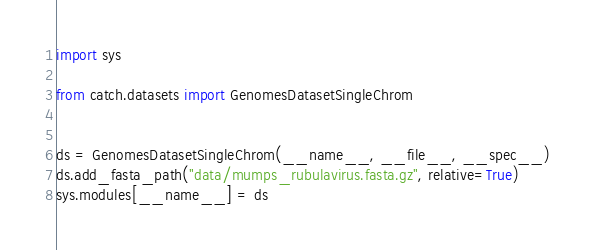<code> <loc_0><loc_0><loc_500><loc_500><_Python_>import sys

from catch.datasets import GenomesDatasetSingleChrom


ds = GenomesDatasetSingleChrom(__name__, __file__, __spec__)
ds.add_fasta_path("data/mumps_rubulavirus.fasta.gz", relative=True)
sys.modules[__name__] = ds
</code> 